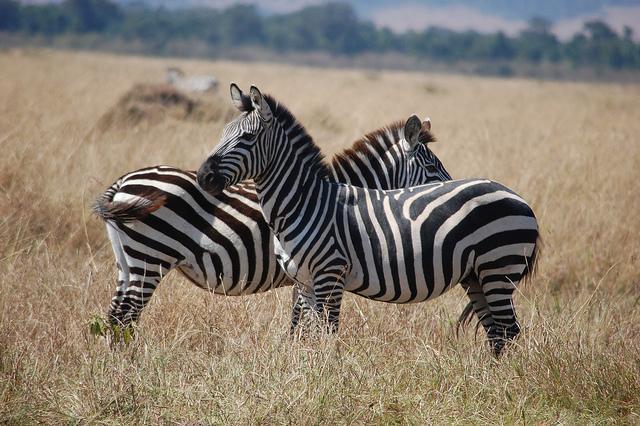How many animals are in this scene?
Give a very brief answer. 2. How many zebras are there?
Give a very brief answer. 2. 